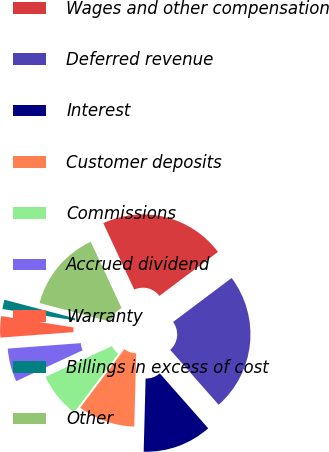<chart> <loc_0><loc_0><loc_500><loc_500><pie_chart><fcel>Wages and other compensation<fcel>Deferred revenue<fcel>Interest<fcel>Customer deposits<fcel>Commissions<fcel>Accrued dividend<fcel>Warranty<fcel>Billings in excess of cost<fcel>Other<nl><fcel>21.68%<fcel>23.75%<fcel>11.92%<fcel>9.86%<fcel>7.8%<fcel>5.73%<fcel>3.67%<fcel>1.61%<fcel>13.98%<nl></chart> 